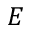Convert formula to latex. <formula><loc_0><loc_0><loc_500><loc_500>E</formula> 